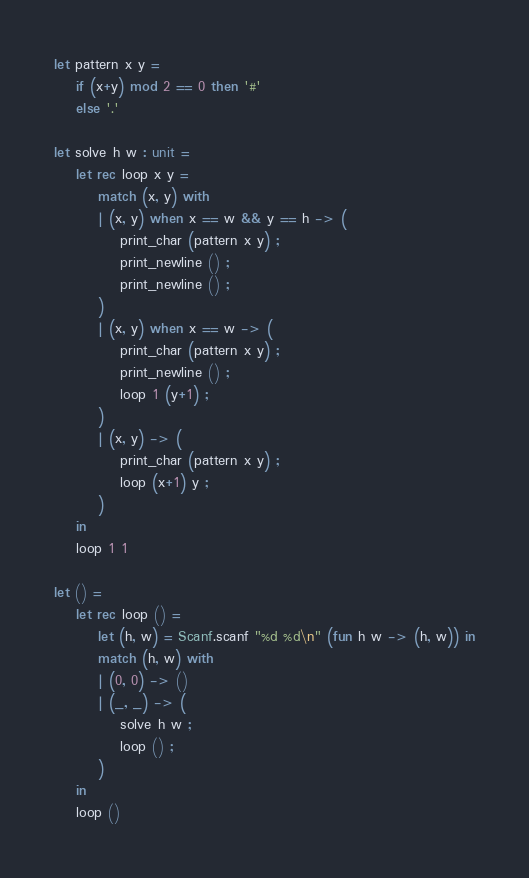Convert code to text. <code><loc_0><loc_0><loc_500><loc_500><_OCaml_>let pattern x y =
    if (x+y) mod 2 == 0 then '#'
    else '.'

let solve h w : unit =
    let rec loop x y =
        match (x, y) with
        | (x, y) when x == w && y == h -> (
            print_char (pattern x y) ;
            print_newline () ;
            print_newline () ;
        )
        | (x, y) when x == w -> (
            print_char (pattern x y) ;
            print_newline () ;
            loop 1 (y+1) ;
        )
        | (x, y) -> (
            print_char (pattern x y) ;
            loop (x+1) y ;
        )
    in
    loop 1 1

let () =
    let rec loop () =
        let (h, w) = Scanf.scanf "%d %d\n" (fun h w -> (h, w)) in
        match (h, w) with
        | (0, 0) -> ()
        | (_, _) -> (
            solve h w ;
            loop () ;
        )
    in
    loop ()</code> 